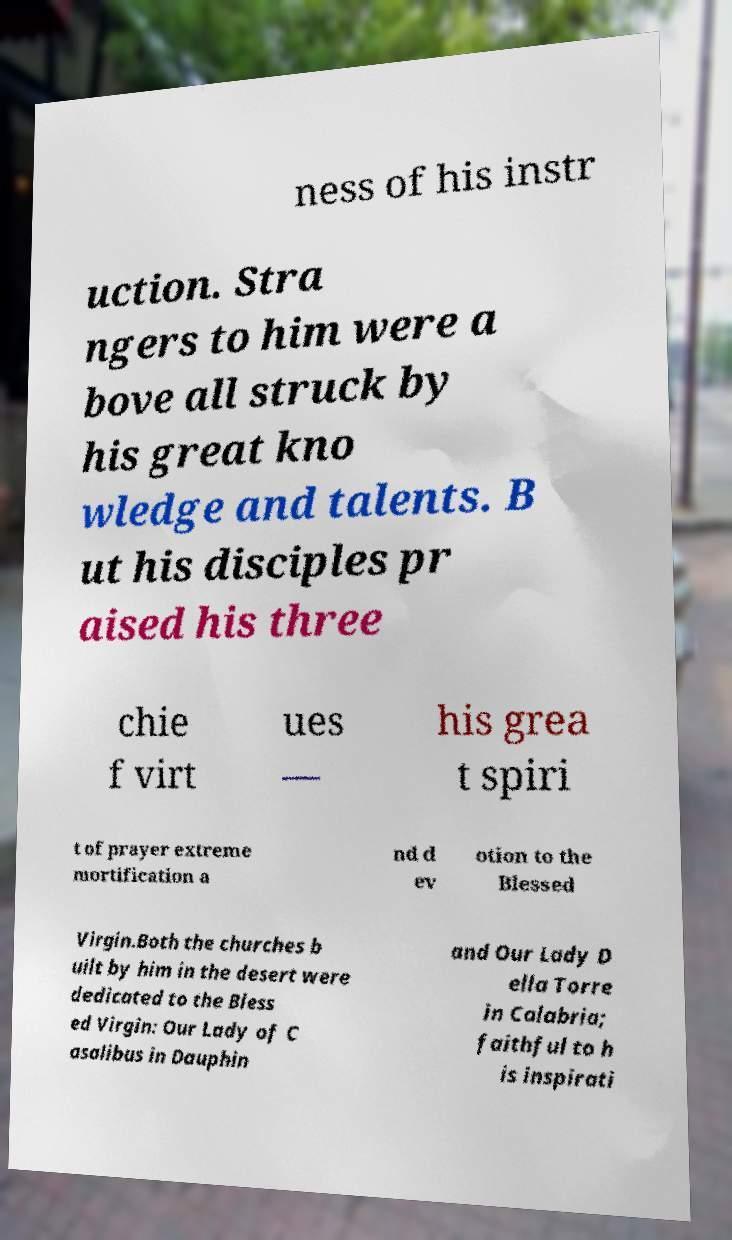Can you read and provide the text displayed in the image?This photo seems to have some interesting text. Can you extract and type it out for me? ness of his instr uction. Stra ngers to him were a bove all struck by his great kno wledge and talents. B ut his disciples pr aised his three chie f virt ues — his grea t spiri t of prayer extreme mortification a nd d ev otion to the Blessed Virgin.Both the churches b uilt by him in the desert were dedicated to the Bless ed Virgin: Our Lady of C asalibus in Dauphin and Our Lady D ella Torre in Calabria; faithful to h is inspirati 